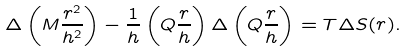<formula> <loc_0><loc_0><loc_500><loc_500>\Delta \left ( M \frac { r ^ { 2 } } { h ^ { 2 } } \right ) - \frac { 1 } { h } \left ( Q \frac { r } { h } \right ) \Delta \left ( Q \frac { r } { h } \right ) = T \Delta S ( r ) .</formula> 